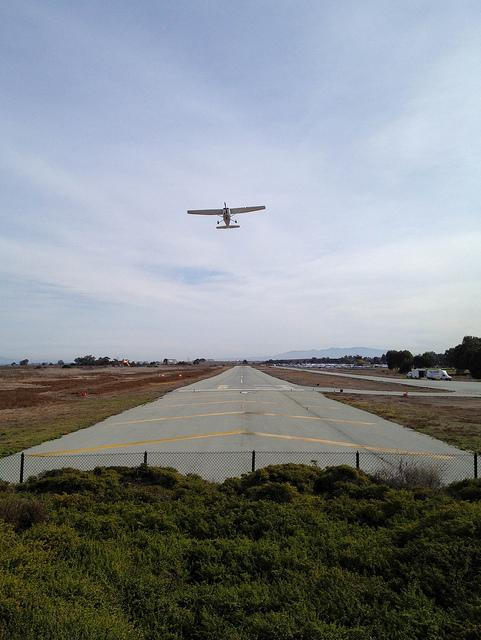What is the plane pictured above doing?

Choices:
A) take off
B) stopped
C) landing
D) fuelling take off 